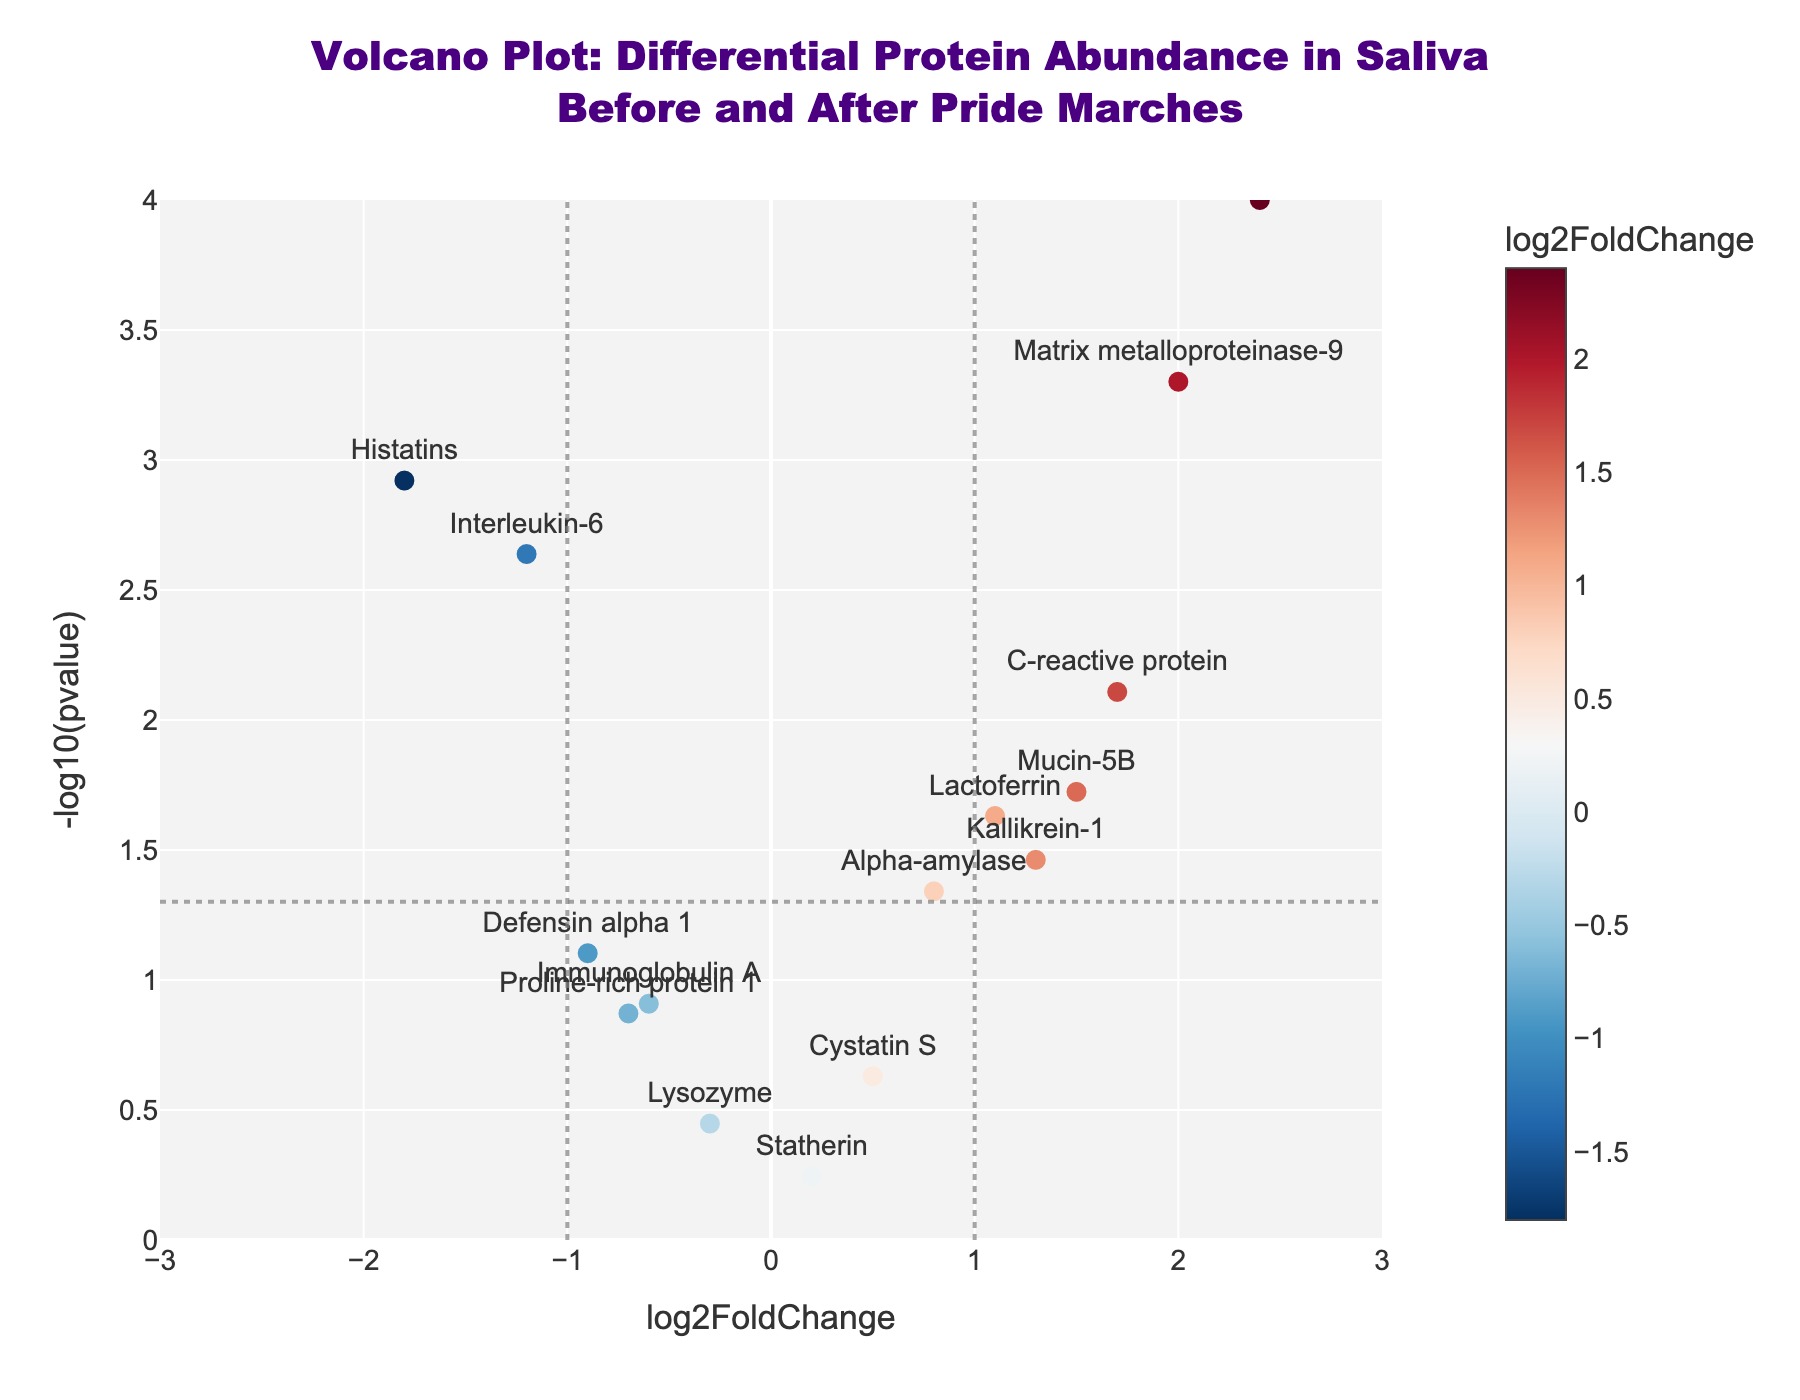what is the title of the figure? The title can be read at the top of the figure. It states the main subject of the plot regarding differential protein abundance in saliva samples before and after pride marches.
Answer: "Volcano Plot: Differential Protein Abundance in Saliva Before and After Pride Marches" how is the -log10(pvalue) of Alpha-amylase represented in the plot? The plot shows that Alpha-amylase has a log2FoldChange of 0.8 and a pvalue of 0.0456. Converting the pvalue to -log10(pvalue) gives approximately 1.34. This can be found around the y-axis value.
Answer: Approximately 1.34 which protein has the highest log2FoldChange and what is its pvalue? By looking at the scatter points along the x-axis, the protein with the highest log2FoldChange is Cortisol. Its corresponding pvalue is displayed in the hover text when hovering over this point in the plot.
Answer: Cortisol, 0.0001 how many proteins have a significant pvalue below 0.05? The significance threshold is represented by the horizontal line at -log10(pvalue) = 1.3. Counting the scatter points above this threshold gives us the number of significant proteins.
Answer: 7 proteins is there any protein with negative log2FoldChange and significant pvalue below 0.05? For a protein to meet both criteria, check scatter points on the left side of the threshold lines (x-axis at -1) and above the significance line (y-axis at 1.3). Histatins and Interleukin-6 meet these criteria.
Answer: Yes, Histatins and Interleukin-6 compare the abundance change of Kallikrein-1 and C-reactive protein. Which has a higher log2FoldChange? By locating the scatter points and hover texts for both proteins, compare their log2FoldChange values directly from the plot. Kallikrein-1 has 1.3 and C-reactive protein has 1.7, so C-reactive protein has a higher change.
Answer: C-reactive protein what are the log2FoldChange and -log10(pvalue) for Matrix metalloproteinase-9? The hover text over the scatter point for Matrix metalloproteinase-9 gives us both values: log2FoldChange is 2.0 and -log10(pvalue) is derived from the pvalue of 0.0005, which equates to 3.30.
Answer: log2FoldChange: 2.0, -log10(pvalue): 3.30 which protein shows the smallest positive log2FoldChange and is it significant? Analyze the scatter points along the positive side of the log2FoldChange axis. The smallest positive value is for Statherin, which is around 0.2. The significance is judged by its position relative to the horizontal line at -log10(pvalue) = 1.3. Statherin has a pvalue above 0.05, making it not significant.
Answer: Statherin, Not significant how many proteins have a log2FoldChange greater than 1.5? Which are they? Locate scatter points to the right of the 1.5 value on the x-axis. There are three proteins: Cortisol, Matrix metalloproteinase-9, and C-reactive protein.
Answer: 3 proteins: Cortisol, Matrix metalloproteinase-9, C-reactive protein 